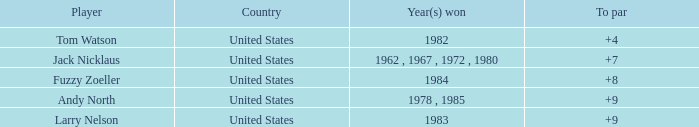What is the sum for the player with a to par of 4? 1.0. 